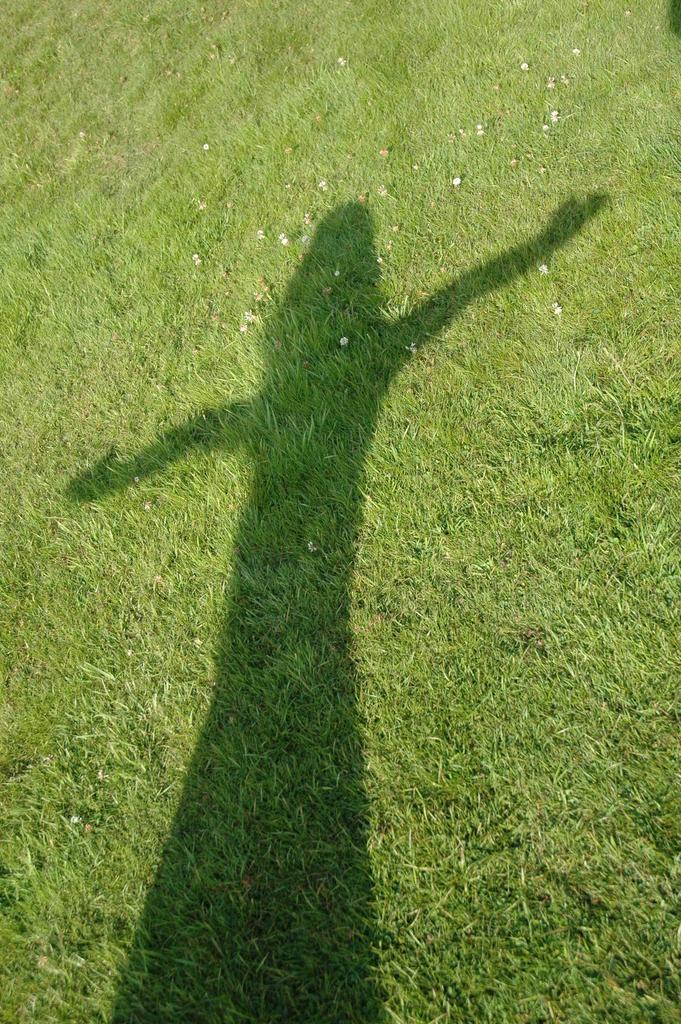What type of vegetation is present in the image? There is grass in the image. Can you describe any other features in the image? There is a shadow of a person in the center of the image. What type of art is being displayed in the image? There is no art present in the image; it features grass and a shadow of a person. What disease is affecting the person whose shadow is in the image? There is no indication of any disease affecting the person in the image, as only their shadow is visible. 